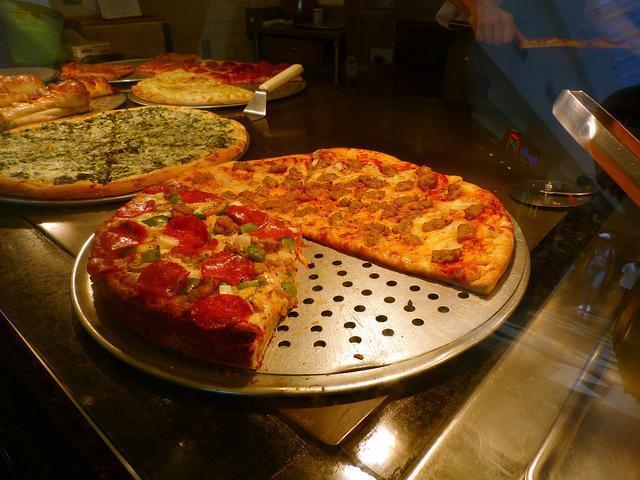Is "The person is far from the oven." an appropriate description for the image?
Answer yes or no. No. 